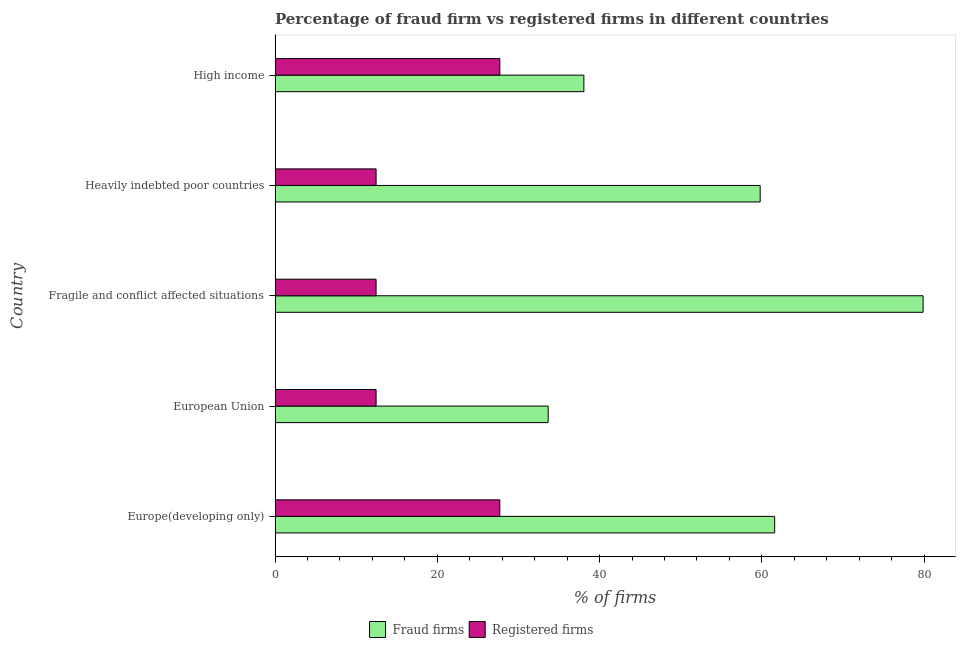How many groups of bars are there?
Your answer should be very brief. 5. How many bars are there on the 5th tick from the bottom?
Provide a short and direct response. 2. What is the label of the 4th group of bars from the top?
Ensure brevity in your answer.  European Union. What is the percentage of registered firms in Heavily indebted poor countries?
Offer a very short reply. 12.45. Across all countries, what is the maximum percentage of fraud firms?
Offer a very short reply. 79.87. Across all countries, what is the minimum percentage of registered firms?
Offer a terse response. 12.45. In which country was the percentage of registered firms maximum?
Your response must be concise. Europe(developing only). In which country was the percentage of fraud firms minimum?
Your answer should be very brief. European Union. What is the total percentage of registered firms in the graph?
Your response must be concise. 92.75. What is the difference between the percentage of registered firms in Europe(developing only) and that in High income?
Keep it short and to the point. 0. What is the difference between the percentage of registered firms in Europe(developing only) and the percentage of fraud firms in Heavily indebted poor countries?
Give a very brief answer. -32.09. What is the average percentage of fraud firms per country?
Your response must be concise. 54.59. What is the difference between the percentage of registered firms and percentage of fraud firms in Europe(developing only)?
Offer a very short reply. -33.88. In how many countries, is the percentage of registered firms greater than 44 %?
Your response must be concise. 0. Is the percentage of fraud firms in European Union less than that in High income?
Offer a very short reply. Yes. What is the difference between the highest and the second highest percentage of registered firms?
Your response must be concise. 0. What is the difference between the highest and the lowest percentage of registered firms?
Offer a very short reply. 15.25. What does the 2nd bar from the top in Europe(developing only) represents?
Keep it short and to the point. Fraud firms. What does the 1st bar from the bottom in European Union represents?
Your answer should be compact. Fraud firms. How many bars are there?
Your response must be concise. 10. Are all the bars in the graph horizontal?
Keep it short and to the point. Yes. Are the values on the major ticks of X-axis written in scientific E-notation?
Give a very brief answer. No. How are the legend labels stacked?
Your answer should be compact. Horizontal. What is the title of the graph?
Give a very brief answer. Percentage of fraud firm vs registered firms in different countries. Does "Young" appear as one of the legend labels in the graph?
Offer a terse response. No. What is the label or title of the X-axis?
Offer a very short reply. % of firms. What is the label or title of the Y-axis?
Give a very brief answer. Country. What is the % of firms in Fraud firms in Europe(developing only)?
Keep it short and to the point. 61.58. What is the % of firms in Registered firms in Europe(developing only)?
Give a very brief answer. 27.7. What is the % of firms of Fraud firms in European Union?
Your answer should be compact. 33.66. What is the % of firms of Registered firms in European Union?
Provide a short and direct response. 12.45. What is the % of firms of Fraud firms in Fragile and conflict affected situations?
Give a very brief answer. 79.87. What is the % of firms of Registered firms in Fragile and conflict affected situations?
Keep it short and to the point. 12.45. What is the % of firms of Fraud firms in Heavily indebted poor countries?
Provide a succinct answer. 59.79. What is the % of firms in Registered firms in Heavily indebted poor countries?
Provide a succinct answer. 12.45. What is the % of firms of Fraud firms in High income?
Your answer should be compact. 38.06. What is the % of firms in Registered firms in High income?
Your answer should be very brief. 27.7. Across all countries, what is the maximum % of firms of Fraud firms?
Offer a very short reply. 79.87. Across all countries, what is the maximum % of firms of Registered firms?
Make the answer very short. 27.7. Across all countries, what is the minimum % of firms in Fraud firms?
Provide a succinct answer. 33.66. Across all countries, what is the minimum % of firms of Registered firms?
Provide a short and direct response. 12.45. What is the total % of firms of Fraud firms in the graph?
Your answer should be compact. 272.95. What is the total % of firms of Registered firms in the graph?
Offer a terse response. 92.75. What is the difference between the % of firms of Fraud firms in Europe(developing only) and that in European Union?
Offer a very short reply. 27.91. What is the difference between the % of firms in Registered firms in Europe(developing only) and that in European Union?
Your answer should be compact. 15.25. What is the difference between the % of firms of Fraud firms in Europe(developing only) and that in Fragile and conflict affected situations?
Ensure brevity in your answer.  -18.3. What is the difference between the % of firms of Registered firms in Europe(developing only) and that in Fragile and conflict affected situations?
Offer a terse response. 15.25. What is the difference between the % of firms of Fraud firms in Europe(developing only) and that in Heavily indebted poor countries?
Keep it short and to the point. 1.78. What is the difference between the % of firms in Registered firms in Europe(developing only) and that in Heavily indebted poor countries?
Your answer should be very brief. 15.25. What is the difference between the % of firms in Fraud firms in Europe(developing only) and that in High income?
Offer a terse response. 23.52. What is the difference between the % of firms of Fraud firms in European Union and that in Fragile and conflict affected situations?
Provide a short and direct response. -46.21. What is the difference between the % of firms in Fraud firms in European Union and that in Heavily indebted poor countries?
Offer a very short reply. -26.13. What is the difference between the % of firms of Registered firms in European Union and that in High income?
Ensure brevity in your answer.  -15.25. What is the difference between the % of firms in Fraud firms in Fragile and conflict affected situations and that in Heavily indebted poor countries?
Give a very brief answer. 20.08. What is the difference between the % of firms in Fraud firms in Fragile and conflict affected situations and that in High income?
Your response must be concise. 41.81. What is the difference between the % of firms in Registered firms in Fragile and conflict affected situations and that in High income?
Keep it short and to the point. -15.25. What is the difference between the % of firms of Fraud firms in Heavily indebted poor countries and that in High income?
Your answer should be compact. 21.73. What is the difference between the % of firms in Registered firms in Heavily indebted poor countries and that in High income?
Your response must be concise. -15.25. What is the difference between the % of firms of Fraud firms in Europe(developing only) and the % of firms of Registered firms in European Union?
Make the answer very short. 49.12. What is the difference between the % of firms of Fraud firms in Europe(developing only) and the % of firms of Registered firms in Fragile and conflict affected situations?
Offer a terse response. 49.12. What is the difference between the % of firms in Fraud firms in Europe(developing only) and the % of firms in Registered firms in Heavily indebted poor countries?
Provide a succinct answer. 49.12. What is the difference between the % of firms in Fraud firms in Europe(developing only) and the % of firms in Registered firms in High income?
Ensure brevity in your answer.  33.88. What is the difference between the % of firms in Fraud firms in European Union and the % of firms in Registered firms in Fragile and conflict affected situations?
Your answer should be compact. 21.21. What is the difference between the % of firms in Fraud firms in European Union and the % of firms in Registered firms in Heavily indebted poor countries?
Your answer should be compact. 21.21. What is the difference between the % of firms of Fraud firms in European Union and the % of firms of Registered firms in High income?
Ensure brevity in your answer.  5.96. What is the difference between the % of firms of Fraud firms in Fragile and conflict affected situations and the % of firms of Registered firms in Heavily indebted poor countries?
Provide a succinct answer. 67.42. What is the difference between the % of firms in Fraud firms in Fragile and conflict affected situations and the % of firms in Registered firms in High income?
Your answer should be very brief. 52.17. What is the difference between the % of firms in Fraud firms in Heavily indebted poor countries and the % of firms in Registered firms in High income?
Offer a very short reply. 32.09. What is the average % of firms in Fraud firms per country?
Give a very brief answer. 54.59. What is the average % of firms of Registered firms per country?
Offer a terse response. 18.55. What is the difference between the % of firms of Fraud firms and % of firms of Registered firms in Europe(developing only)?
Keep it short and to the point. 33.88. What is the difference between the % of firms in Fraud firms and % of firms in Registered firms in European Union?
Provide a short and direct response. 21.21. What is the difference between the % of firms of Fraud firms and % of firms of Registered firms in Fragile and conflict affected situations?
Give a very brief answer. 67.42. What is the difference between the % of firms of Fraud firms and % of firms of Registered firms in Heavily indebted poor countries?
Keep it short and to the point. 47.34. What is the difference between the % of firms in Fraud firms and % of firms in Registered firms in High income?
Make the answer very short. 10.36. What is the ratio of the % of firms in Fraud firms in Europe(developing only) to that in European Union?
Offer a terse response. 1.83. What is the ratio of the % of firms of Registered firms in Europe(developing only) to that in European Union?
Provide a short and direct response. 2.22. What is the ratio of the % of firms of Fraud firms in Europe(developing only) to that in Fragile and conflict affected situations?
Provide a succinct answer. 0.77. What is the ratio of the % of firms in Registered firms in Europe(developing only) to that in Fragile and conflict affected situations?
Your answer should be very brief. 2.22. What is the ratio of the % of firms of Fraud firms in Europe(developing only) to that in Heavily indebted poor countries?
Offer a very short reply. 1.03. What is the ratio of the % of firms in Registered firms in Europe(developing only) to that in Heavily indebted poor countries?
Ensure brevity in your answer.  2.22. What is the ratio of the % of firms in Fraud firms in Europe(developing only) to that in High income?
Ensure brevity in your answer.  1.62. What is the ratio of the % of firms in Registered firms in Europe(developing only) to that in High income?
Your answer should be very brief. 1. What is the ratio of the % of firms in Fraud firms in European Union to that in Fragile and conflict affected situations?
Provide a short and direct response. 0.42. What is the ratio of the % of firms of Registered firms in European Union to that in Fragile and conflict affected situations?
Offer a very short reply. 1. What is the ratio of the % of firms of Fraud firms in European Union to that in Heavily indebted poor countries?
Your response must be concise. 0.56. What is the ratio of the % of firms of Fraud firms in European Union to that in High income?
Offer a very short reply. 0.88. What is the ratio of the % of firms of Registered firms in European Union to that in High income?
Offer a terse response. 0.45. What is the ratio of the % of firms in Fraud firms in Fragile and conflict affected situations to that in Heavily indebted poor countries?
Ensure brevity in your answer.  1.34. What is the ratio of the % of firms of Registered firms in Fragile and conflict affected situations to that in Heavily indebted poor countries?
Ensure brevity in your answer.  1. What is the ratio of the % of firms of Fraud firms in Fragile and conflict affected situations to that in High income?
Your answer should be very brief. 2.1. What is the ratio of the % of firms in Registered firms in Fragile and conflict affected situations to that in High income?
Offer a very short reply. 0.45. What is the ratio of the % of firms of Fraud firms in Heavily indebted poor countries to that in High income?
Make the answer very short. 1.57. What is the ratio of the % of firms of Registered firms in Heavily indebted poor countries to that in High income?
Your answer should be compact. 0.45. What is the difference between the highest and the second highest % of firms in Fraud firms?
Ensure brevity in your answer.  18.3. What is the difference between the highest and the lowest % of firms in Fraud firms?
Keep it short and to the point. 46.21. What is the difference between the highest and the lowest % of firms of Registered firms?
Your answer should be compact. 15.25. 